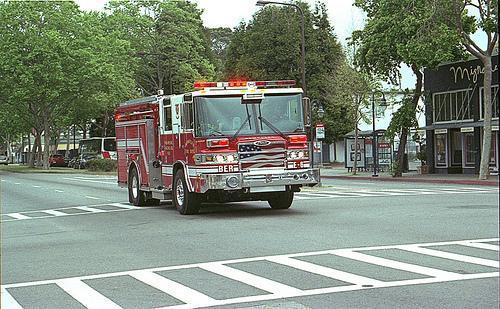How many tires can you see?
Give a very brief answer. 3. How many lamp posts are in the photo?
Give a very brief answer. 1. 